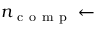<formula> <loc_0><loc_0><loc_500><loc_500>n _ { c o m p } \leftarrow</formula> 